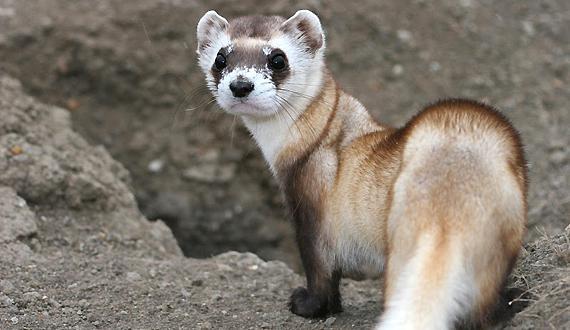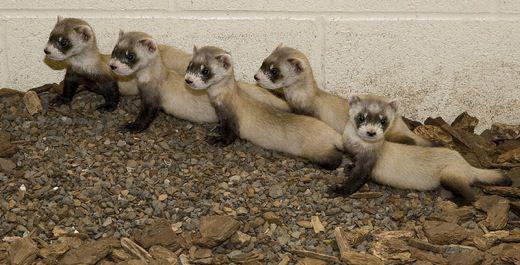The first image is the image on the left, the second image is the image on the right. Analyze the images presented: Is the assertion "A ferret is partially underground." valid? Answer yes or no. No. The first image is the image on the left, the second image is the image on the right. Analyze the images presented: Is the assertion "At least one of the images shows a ferret with a head turned away from the animal's sagittal plane." valid? Answer yes or no. Yes. 